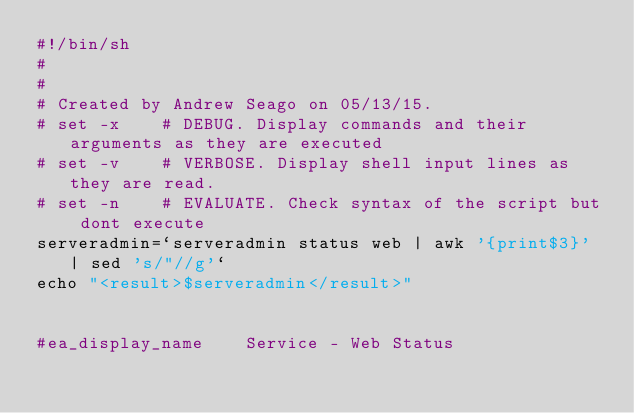<code> <loc_0><loc_0><loc_500><loc_500><_Bash_>#!/bin/sh
#
#
# Created by Andrew Seago on 05/13/15.
# set -x	# DEBUG. Display commands and their arguments as they are executed
# set -v	# VERBOSE. Display shell input lines as they are read.
# set -n	# EVALUATE. Check syntax of the script but dont execute
serveradmin=`serveradmin status web | awk '{print$3}' | sed 's/"//g'`
echo "<result>$serveradmin</result>"


#ea_display_name	Service - Web Status
</code> 